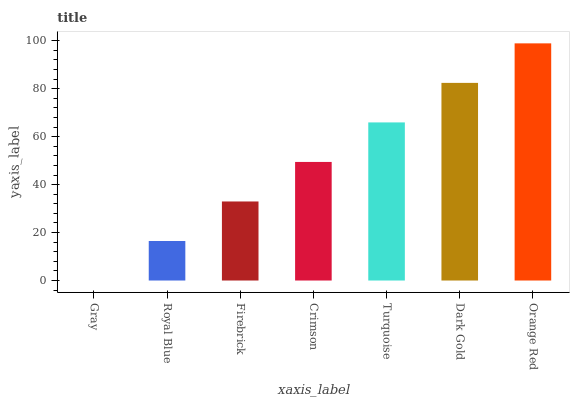Is Royal Blue the minimum?
Answer yes or no. No. Is Royal Blue the maximum?
Answer yes or no. No. Is Royal Blue greater than Gray?
Answer yes or no. Yes. Is Gray less than Royal Blue?
Answer yes or no. Yes. Is Gray greater than Royal Blue?
Answer yes or no. No. Is Royal Blue less than Gray?
Answer yes or no. No. Is Crimson the high median?
Answer yes or no. Yes. Is Crimson the low median?
Answer yes or no. Yes. Is Turquoise the high median?
Answer yes or no. No. Is Dark Gold the low median?
Answer yes or no. No. 